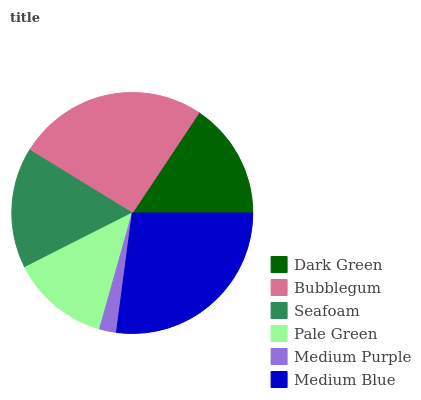Is Medium Purple the minimum?
Answer yes or no. Yes. Is Medium Blue the maximum?
Answer yes or no. Yes. Is Bubblegum the minimum?
Answer yes or no. No. Is Bubblegum the maximum?
Answer yes or no. No. Is Bubblegum greater than Dark Green?
Answer yes or no. Yes. Is Dark Green less than Bubblegum?
Answer yes or no. Yes. Is Dark Green greater than Bubblegum?
Answer yes or no. No. Is Bubblegum less than Dark Green?
Answer yes or no. No. Is Seafoam the high median?
Answer yes or no. Yes. Is Dark Green the low median?
Answer yes or no. Yes. Is Dark Green the high median?
Answer yes or no. No. Is Medium Purple the low median?
Answer yes or no. No. 